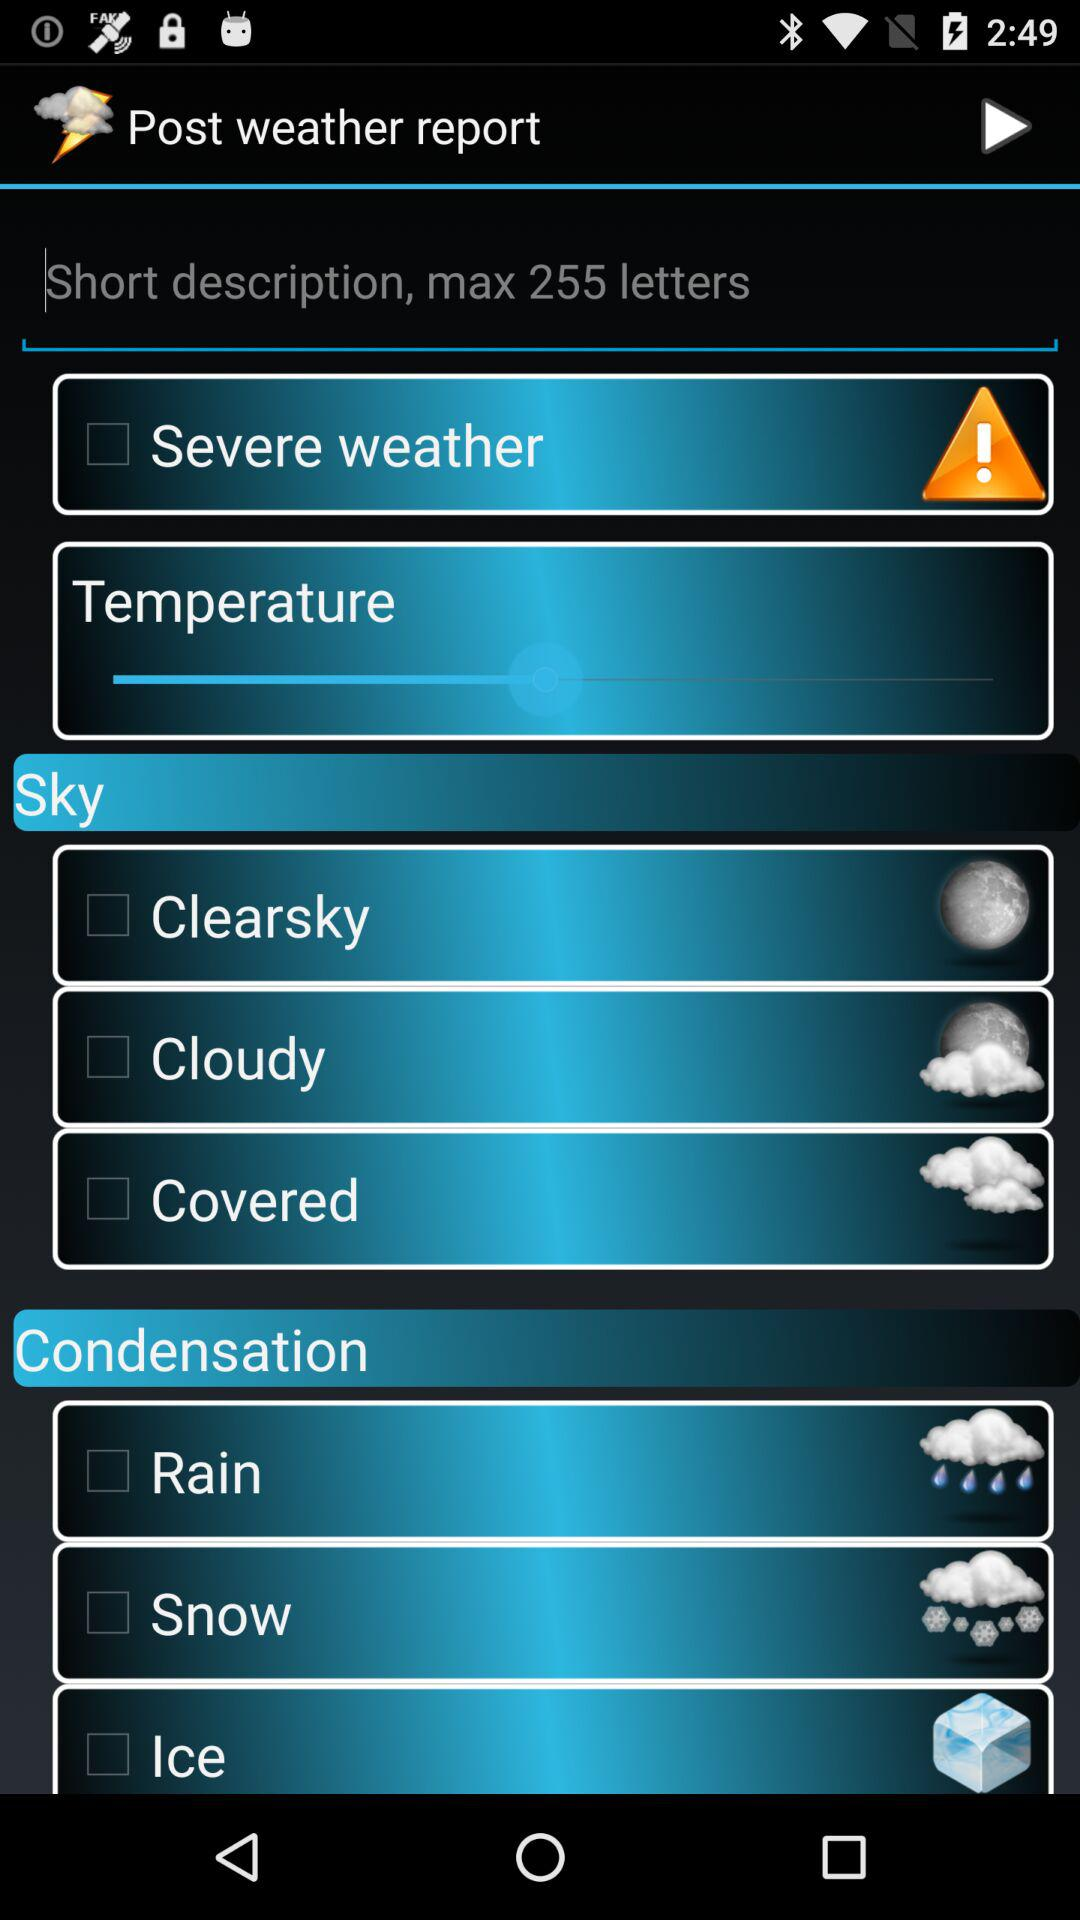What kind of weather description is it? It is a short description. 